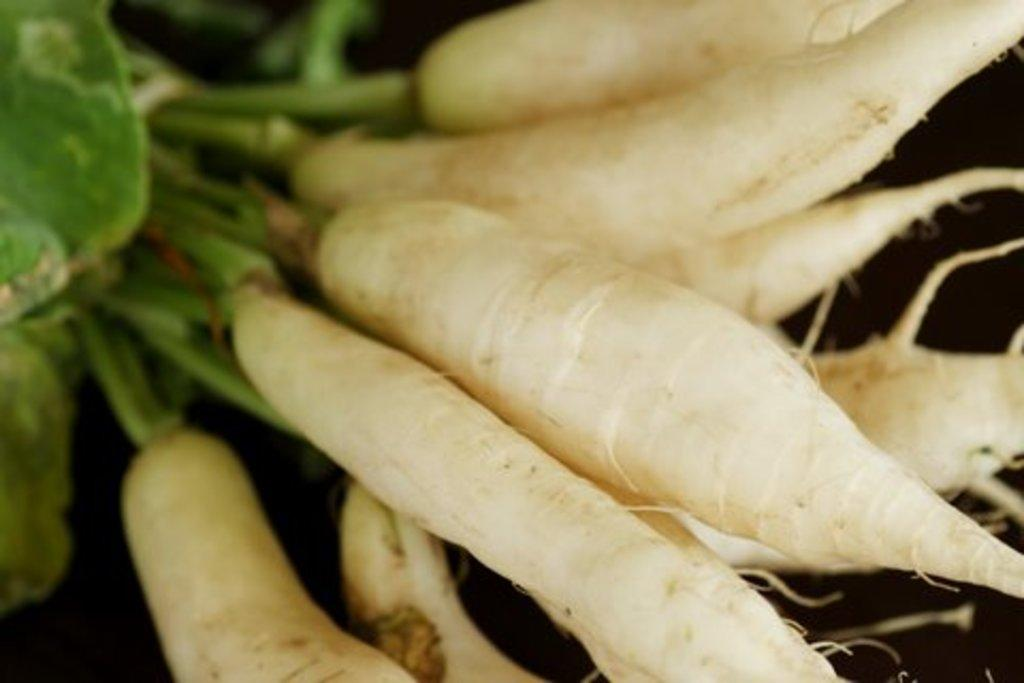What type of vegetable is present in the image? There are radishes in the image. How many boys can be seen playing in the carriage in the image? There are no boys or carriages present in the image; it only features radishes. 